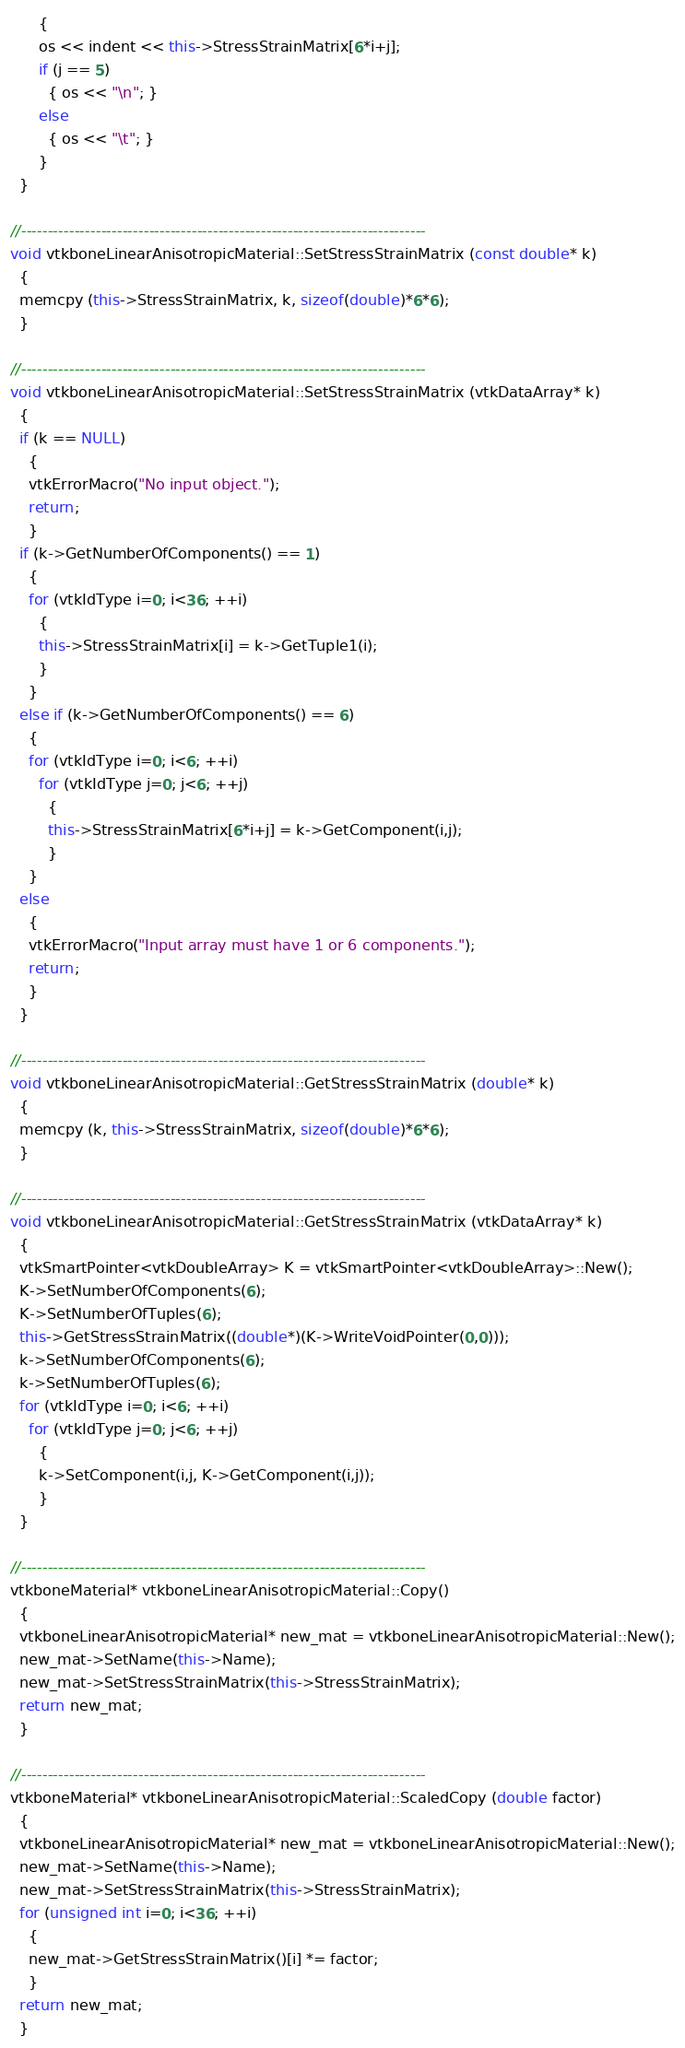<code> <loc_0><loc_0><loc_500><loc_500><_C++_>      {
      os << indent << this->StressStrainMatrix[6*i+j];
      if (j == 5)
        { os << "\n"; }
      else
        { os << "\t"; }
      }
  }

//----------------------------------------------------------------------------
void vtkboneLinearAnisotropicMaterial::SetStressStrainMatrix (const double* k)
  {
  memcpy (this->StressStrainMatrix, k, sizeof(double)*6*6);
  }

//----------------------------------------------------------------------------
void vtkboneLinearAnisotropicMaterial::SetStressStrainMatrix (vtkDataArray* k)
  {
  if (k == NULL)
    {
    vtkErrorMacro("No input object.");
    return;
    }
  if (k->GetNumberOfComponents() == 1)
    {
    for (vtkIdType i=0; i<36; ++i)
      {
      this->StressStrainMatrix[i] = k->GetTuple1(i);
      }
    }
  else if (k->GetNumberOfComponents() == 6)
    {
    for (vtkIdType i=0; i<6; ++i)
      for (vtkIdType j=0; j<6; ++j)
        {
        this->StressStrainMatrix[6*i+j] = k->GetComponent(i,j);
        }
    }
  else
    {
    vtkErrorMacro("Input array must have 1 or 6 components.");
    return;
    }
  }

//----------------------------------------------------------------------------
void vtkboneLinearAnisotropicMaterial::GetStressStrainMatrix (double* k)
  {
  memcpy (k, this->StressStrainMatrix, sizeof(double)*6*6);
  }

//----------------------------------------------------------------------------
void vtkboneLinearAnisotropicMaterial::GetStressStrainMatrix (vtkDataArray* k)
  {
  vtkSmartPointer<vtkDoubleArray> K = vtkSmartPointer<vtkDoubleArray>::New();
  K->SetNumberOfComponents(6);
  K->SetNumberOfTuples(6);
  this->GetStressStrainMatrix((double*)(K->WriteVoidPointer(0,0)));
  k->SetNumberOfComponents(6);
  k->SetNumberOfTuples(6);
  for (vtkIdType i=0; i<6; ++i)
    for (vtkIdType j=0; j<6; ++j)
      {
      k->SetComponent(i,j, K->GetComponent(i,j));
      }
  }

//----------------------------------------------------------------------------
vtkboneMaterial* vtkboneLinearAnisotropicMaterial::Copy()
  {
  vtkboneLinearAnisotropicMaterial* new_mat = vtkboneLinearAnisotropicMaterial::New();
  new_mat->SetName(this->Name);
  new_mat->SetStressStrainMatrix(this->StressStrainMatrix);
  return new_mat;
  }

//----------------------------------------------------------------------------
vtkboneMaterial* vtkboneLinearAnisotropicMaterial::ScaledCopy (double factor)
  {
  vtkboneLinearAnisotropicMaterial* new_mat = vtkboneLinearAnisotropicMaterial::New();
  new_mat->SetName(this->Name);
  new_mat->SetStressStrainMatrix(this->StressStrainMatrix);
  for (unsigned int i=0; i<36; ++i)
    {
    new_mat->GetStressStrainMatrix()[i] *= factor;
    }
  return new_mat;
  }
</code> 